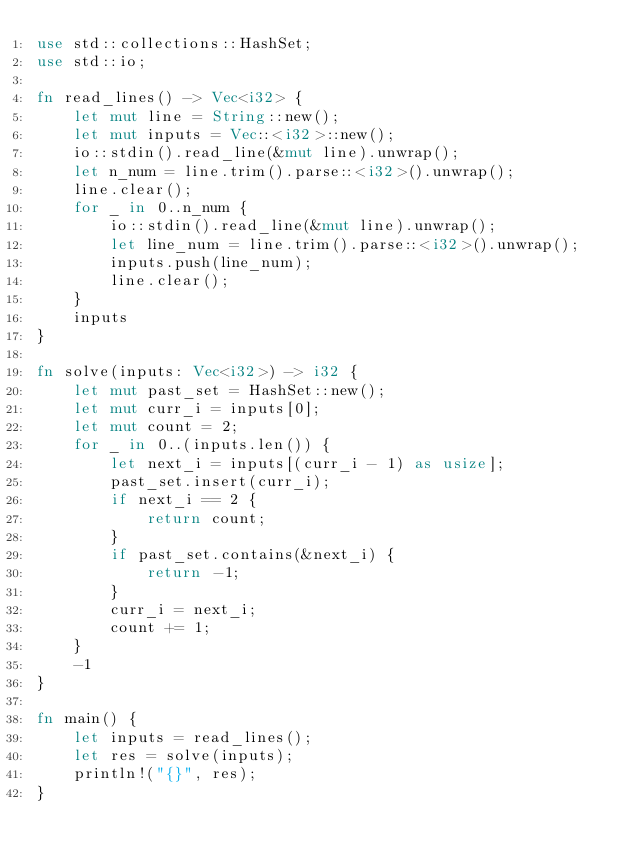Convert code to text. <code><loc_0><loc_0><loc_500><loc_500><_Rust_>use std::collections::HashSet;
use std::io;

fn read_lines() -> Vec<i32> {
    let mut line = String::new();
    let mut inputs = Vec::<i32>::new();
    io::stdin().read_line(&mut line).unwrap();
    let n_num = line.trim().parse::<i32>().unwrap();
    line.clear();
    for _ in 0..n_num {
        io::stdin().read_line(&mut line).unwrap();
        let line_num = line.trim().parse::<i32>().unwrap();
        inputs.push(line_num);
        line.clear();
    }
    inputs
}

fn solve(inputs: Vec<i32>) -> i32 {
    let mut past_set = HashSet::new();
    let mut curr_i = inputs[0];
    let mut count = 2;
    for _ in 0..(inputs.len()) {
        let next_i = inputs[(curr_i - 1) as usize];
        past_set.insert(curr_i);
        if next_i == 2 {
            return count;
        }
        if past_set.contains(&next_i) {
            return -1;
        }
        curr_i = next_i;
        count += 1;
    }
    -1
}

fn main() {
    let inputs = read_lines();
    let res = solve(inputs);
    println!("{}", res);
}
</code> 